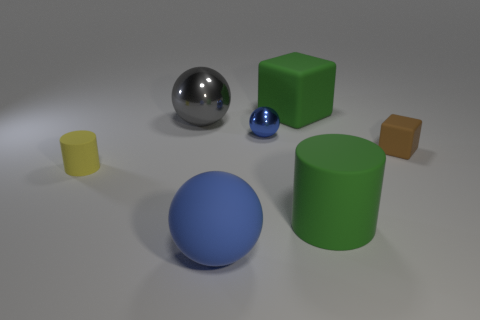Subtract all blue spheres. How many were subtracted if there are1blue spheres left? 1 Add 2 rubber cubes. How many objects exist? 9 Subtract all cubes. How many objects are left? 5 Add 2 small blue metal spheres. How many small blue metal spheres are left? 3 Add 1 big blocks. How many big blocks exist? 2 Subtract 0 purple blocks. How many objects are left? 7 Subtract all big matte balls. Subtract all tiny brown things. How many objects are left? 5 